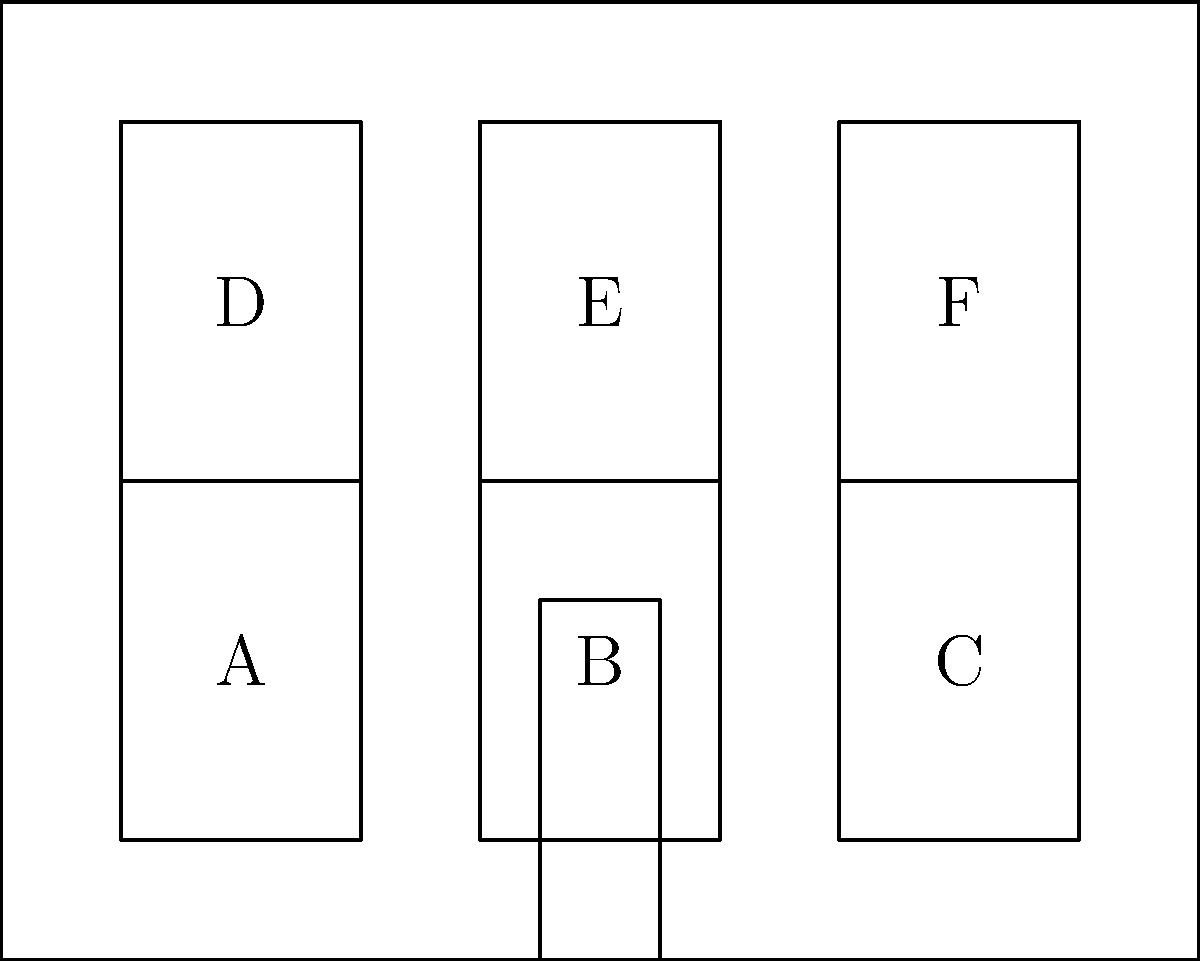In the architectural facade shown above, identify all pairs of congruent windows. Which geometric transformation(s) can be applied to map one window onto another in each congruent pair? To solve this problem, we need to follow these steps:

1. Understand congruence: Two geometric figures are congruent if they have the same shape and size, regardless of their position or orientation.

2. Identify congruent windows:
   - All windows appear to be the same size and shape (rectangles).
   - There are six windows labeled A, B, C, D, E, and F.

3. List all congruent pairs:
   - A and B
   - A and C
   - A and D
   - A and E
   - A and F
   - B and C
   - B and D
   - B and E
   - B and F
   - C and D
   - C and E
   - C and F
   - D and E
   - D and F
   - E and F

4. Identify transformations:
   - Translation: Sliding a figure without rotating or flipping it.
   - Reflection: Flipping a figure over a line.
   - Rotation: Turning a figure around a point.

5. Determine transformations for each pair:
   - Horizontal pairs (e.g., A to B, B to C): Translation
   - Vertical pairs (e.g., A to D, B to E): Translation
   - Diagonal pairs (e.g., A to E, B to F): Translation
   - No rotations or reflections are needed for any pair.

Therefore, all windows are congruent to each other, and translation is the only transformation needed to map one window onto another in each congruent pair.
Answer: All windows are congruent; translation. 